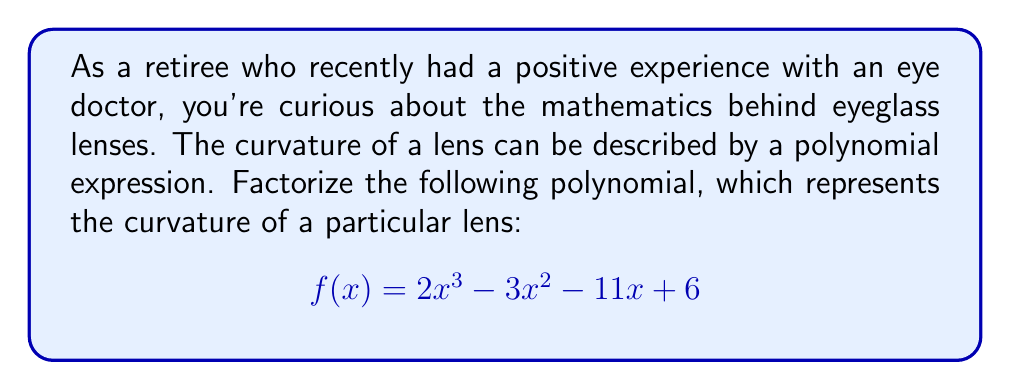Show me your answer to this math problem. Let's factorize this polynomial step-by-step:

1) First, we'll check if there are any common factors. In this case, there are none.

2) Next, we'll use the rational root theorem to find possible roots. The possible rational roots are the factors of the constant term (6): ±1, ±2, ±3, ±6.

3) Let's test these values:
   $f(1) = 2 - 3 - 11 + 6 = -6$
   $f(-1) = -2 - 3 + 11 + 6 = 12$
   $f(2) = 16 - 12 - 22 + 6 = -12$
   $f(-2) = -16 - 12 + 22 + 6 = 0$

4) We found that $f(-2) = 0$, so $(x+2)$ is a factor.

5) Divide $f(x)$ by $(x+2)$:
   $$\frac{2x^3 - 3x^2 - 11x + 6}{x+2} = 2x^2 - 7x + 3$$

6) Now we need to factorize $2x^2 - 7x + 3$. Let's use the quadratic formula:
   $$x = \frac{-b \pm \sqrt{b^2 - 4ac}}{2a}$$
   $$x = \frac{7 \pm \sqrt{49 - 24}}{4} = \frac{7 \pm 5}{4}$$

7) This gives us two more roots: $x = 3/2$ and $x = 1/2$

8) Therefore, the factorized form is:
   $$f(x) = (x+2)(2x-3)(x-\frac{1}{2})$$

9) To get rid of the fraction, multiply everything by 2:
   $$f(x) = 2(x+2)(x-\frac{3}{2})(x-\frac{1}{2})$$
Answer: $$2(x+2)(x-\frac{3}{2})(x-\frac{1}{2})$$ 